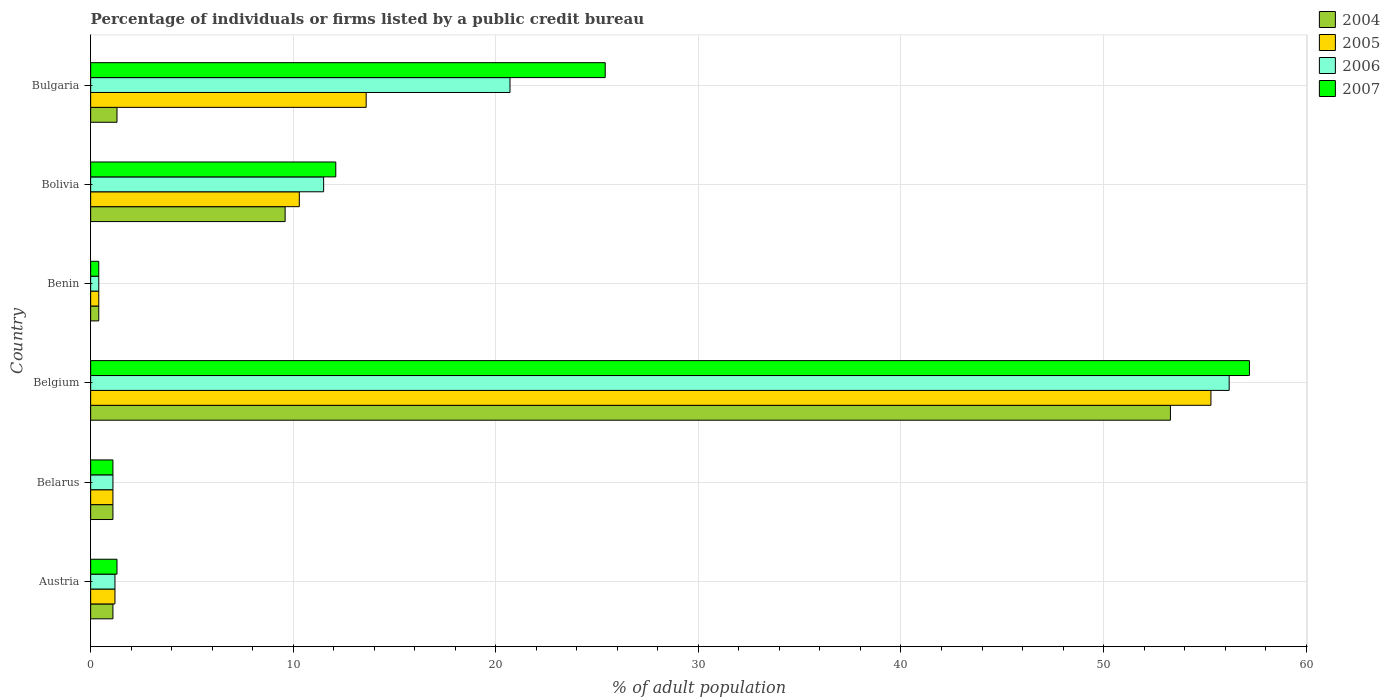How many different coloured bars are there?
Provide a succinct answer. 4. How many groups of bars are there?
Ensure brevity in your answer.  6. Are the number of bars per tick equal to the number of legend labels?
Keep it short and to the point. Yes. How many bars are there on the 1st tick from the top?
Your response must be concise. 4. How many bars are there on the 6th tick from the bottom?
Make the answer very short. 4. What is the label of the 5th group of bars from the top?
Keep it short and to the point. Belarus. Across all countries, what is the maximum percentage of population listed by a public credit bureau in 2005?
Your answer should be very brief. 55.3. Across all countries, what is the minimum percentage of population listed by a public credit bureau in 2007?
Your answer should be very brief. 0.4. In which country was the percentage of population listed by a public credit bureau in 2004 maximum?
Give a very brief answer. Belgium. In which country was the percentage of population listed by a public credit bureau in 2006 minimum?
Make the answer very short. Benin. What is the total percentage of population listed by a public credit bureau in 2005 in the graph?
Keep it short and to the point. 81.9. What is the difference between the percentage of population listed by a public credit bureau in 2007 in Belarus and that in Bulgaria?
Give a very brief answer. -24.3. What is the difference between the percentage of population listed by a public credit bureau in 2005 in Austria and the percentage of population listed by a public credit bureau in 2004 in Bulgaria?
Offer a very short reply. -0.1. What is the average percentage of population listed by a public credit bureau in 2006 per country?
Offer a very short reply. 15.18. What is the difference between the percentage of population listed by a public credit bureau in 2006 and percentage of population listed by a public credit bureau in 2007 in Bulgaria?
Make the answer very short. -4.7. In how many countries, is the percentage of population listed by a public credit bureau in 2005 greater than 38 %?
Give a very brief answer. 1. What is the ratio of the percentage of population listed by a public credit bureau in 2007 in Benin to that in Bulgaria?
Provide a succinct answer. 0.02. What is the difference between the highest and the second highest percentage of population listed by a public credit bureau in 2005?
Ensure brevity in your answer.  41.7. What is the difference between the highest and the lowest percentage of population listed by a public credit bureau in 2004?
Your answer should be compact. 52.9. In how many countries, is the percentage of population listed by a public credit bureau in 2007 greater than the average percentage of population listed by a public credit bureau in 2007 taken over all countries?
Your response must be concise. 2. Is the sum of the percentage of population listed by a public credit bureau in 2006 in Belarus and Belgium greater than the maximum percentage of population listed by a public credit bureau in 2005 across all countries?
Offer a very short reply. Yes. Is it the case that in every country, the sum of the percentage of population listed by a public credit bureau in 2004 and percentage of population listed by a public credit bureau in 2007 is greater than the sum of percentage of population listed by a public credit bureau in 2006 and percentage of population listed by a public credit bureau in 2005?
Give a very brief answer. No. What does the 1st bar from the bottom in Belgium represents?
Offer a terse response. 2004. Is it the case that in every country, the sum of the percentage of population listed by a public credit bureau in 2007 and percentage of population listed by a public credit bureau in 2005 is greater than the percentage of population listed by a public credit bureau in 2006?
Give a very brief answer. Yes. Are all the bars in the graph horizontal?
Your response must be concise. Yes. How many countries are there in the graph?
Offer a very short reply. 6. Does the graph contain grids?
Provide a short and direct response. Yes. Where does the legend appear in the graph?
Provide a succinct answer. Top right. How many legend labels are there?
Provide a short and direct response. 4. How are the legend labels stacked?
Offer a terse response. Vertical. What is the title of the graph?
Give a very brief answer. Percentage of individuals or firms listed by a public credit bureau. Does "1999" appear as one of the legend labels in the graph?
Make the answer very short. No. What is the label or title of the X-axis?
Give a very brief answer. % of adult population. What is the label or title of the Y-axis?
Give a very brief answer. Country. What is the % of adult population of 2004 in Austria?
Offer a terse response. 1.1. What is the % of adult population in 2006 in Austria?
Your answer should be very brief. 1.2. What is the % of adult population in 2004 in Belarus?
Your answer should be compact. 1.1. What is the % of adult population of 2005 in Belarus?
Give a very brief answer. 1.1. What is the % of adult population in 2004 in Belgium?
Give a very brief answer. 53.3. What is the % of adult population in 2005 in Belgium?
Your response must be concise. 55.3. What is the % of adult population in 2006 in Belgium?
Offer a very short reply. 56.2. What is the % of adult population in 2007 in Belgium?
Offer a very short reply. 57.2. What is the % of adult population of 2005 in Benin?
Your answer should be very brief. 0.4. What is the % of adult population of 2006 in Benin?
Your response must be concise. 0.4. What is the % of adult population of 2007 in Bolivia?
Keep it short and to the point. 12.1. What is the % of adult population of 2004 in Bulgaria?
Make the answer very short. 1.3. What is the % of adult population in 2005 in Bulgaria?
Give a very brief answer. 13.6. What is the % of adult population in 2006 in Bulgaria?
Make the answer very short. 20.7. What is the % of adult population of 2007 in Bulgaria?
Your answer should be compact. 25.4. Across all countries, what is the maximum % of adult population in 2004?
Keep it short and to the point. 53.3. Across all countries, what is the maximum % of adult population in 2005?
Make the answer very short. 55.3. Across all countries, what is the maximum % of adult population of 2006?
Your answer should be very brief. 56.2. Across all countries, what is the maximum % of adult population of 2007?
Keep it short and to the point. 57.2. Across all countries, what is the minimum % of adult population of 2006?
Your answer should be compact. 0.4. What is the total % of adult population in 2004 in the graph?
Offer a very short reply. 66.8. What is the total % of adult population in 2005 in the graph?
Your answer should be compact. 81.9. What is the total % of adult population of 2006 in the graph?
Your answer should be compact. 91.1. What is the total % of adult population in 2007 in the graph?
Give a very brief answer. 97.5. What is the difference between the % of adult population of 2004 in Austria and that in Belarus?
Your answer should be compact. 0. What is the difference between the % of adult population of 2005 in Austria and that in Belarus?
Keep it short and to the point. 0.1. What is the difference between the % of adult population of 2006 in Austria and that in Belarus?
Provide a succinct answer. 0.1. What is the difference between the % of adult population of 2007 in Austria and that in Belarus?
Offer a terse response. 0.2. What is the difference between the % of adult population in 2004 in Austria and that in Belgium?
Offer a very short reply. -52.2. What is the difference between the % of adult population in 2005 in Austria and that in Belgium?
Keep it short and to the point. -54.1. What is the difference between the % of adult population of 2006 in Austria and that in Belgium?
Your answer should be very brief. -55. What is the difference between the % of adult population of 2007 in Austria and that in Belgium?
Your answer should be very brief. -55.9. What is the difference between the % of adult population of 2005 in Austria and that in Benin?
Your answer should be compact. 0.8. What is the difference between the % of adult population in 2006 in Austria and that in Benin?
Offer a very short reply. 0.8. What is the difference between the % of adult population of 2007 in Austria and that in Benin?
Give a very brief answer. 0.9. What is the difference between the % of adult population of 2005 in Austria and that in Bolivia?
Offer a terse response. -9.1. What is the difference between the % of adult population of 2006 in Austria and that in Bolivia?
Your answer should be very brief. -10.3. What is the difference between the % of adult population in 2005 in Austria and that in Bulgaria?
Offer a terse response. -12.4. What is the difference between the % of adult population in 2006 in Austria and that in Bulgaria?
Your answer should be compact. -19.5. What is the difference between the % of adult population of 2007 in Austria and that in Bulgaria?
Give a very brief answer. -24.1. What is the difference between the % of adult population in 2004 in Belarus and that in Belgium?
Provide a short and direct response. -52.2. What is the difference between the % of adult population of 2005 in Belarus and that in Belgium?
Your answer should be very brief. -54.2. What is the difference between the % of adult population of 2006 in Belarus and that in Belgium?
Your answer should be very brief. -55.1. What is the difference between the % of adult population of 2007 in Belarus and that in Belgium?
Give a very brief answer. -56.1. What is the difference between the % of adult population in 2004 in Belarus and that in Benin?
Give a very brief answer. 0.7. What is the difference between the % of adult population in 2006 in Belarus and that in Benin?
Make the answer very short. 0.7. What is the difference between the % of adult population of 2007 in Belarus and that in Benin?
Make the answer very short. 0.7. What is the difference between the % of adult population of 2004 in Belarus and that in Bolivia?
Your response must be concise. -8.5. What is the difference between the % of adult population in 2006 in Belarus and that in Bolivia?
Ensure brevity in your answer.  -10.4. What is the difference between the % of adult population of 2004 in Belarus and that in Bulgaria?
Your answer should be compact. -0.2. What is the difference between the % of adult population of 2005 in Belarus and that in Bulgaria?
Your answer should be very brief. -12.5. What is the difference between the % of adult population in 2006 in Belarus and that in Bulgaria?
Offer a very short reply. -19.6. What is the difference between the % of adult population of 2007 in Belarus and that in Bulgaria?
Ensure brevity in your answer.  -24.3. What is the difference between the % of adult population of 2004 in Belgium and that in Benin?
Give a very brief answer. 52.9. What is the difference between the % of adult population in 2005 in Belgium and that in Benin?
Ensure brevity in your answer.  54.9. What is the difference between the % of adult population in 2006 in Belgium and that in Benin?
Provide a succinct answer. 55.8. What is the difference between the % of adult population in 2007 in Belgium and that in Benin?
Provide a short and direct response. 56.8. What is the difference between the % of adult population of 2004 in Belgium and that in Bolivia?
Keep it short and to the point. 43.7. What is the difference between the % of adult population in 2005 in Belgium and that in Bolivia?
Offer a terse response. 45. What is the difference between the % of adult population in 2006 in Belgium and that in Bolivia?
Your answer should be very brief. 44.7. What is the difference between the % of adult population of 2007 in Belgium and that in Bolivia?
Your response must be concise. 45.1. What is the difference between the % of adult population in 2005 in Belgium and that in Bulgaria?
Keep it short and to the point. 41.7. What is the difference between the % of adult population in 2006 in Belgium and that in Bulgaria?
Offer a very short reply. 35.5. What is the difference between the % of adult population of 2007 in Belgium and that in Bulgaria?
Ensure brevity in your answer.  31.8. What is the difference between the % of adult population of 2004 in Benin and that in Bolivia?
Provide a short and direct response. -9.2. What is the difference between the % of adult population of 2006 in Benin and that in Bolivia?
Keep it short and to the point. -11.1. What is the difference between the % of adult population in 2007 in Benin and that in Bolivia?
Your answer should be very brief. -11.7. What is the difference between the % of adult population of 2006 in Benin and that in Bulgaria?
Provide a succinct answer. -20.3. What is the difference between the % of adult population in 2007 in Benin and that in Bulgaria?
Give a very brief answer. -25. What is the difference between the % of adult population in 2004 in Bolivia and that in Bulgaria?
Keep it short and to the point. 8.3. What is the difference between the % of adult population of 2005 in Bolivia and that in Bulgaria?
Make the answer very short. -3.3. What is the difference between the % of adult population in 2006 in Bolivia and that in Bulgaria?
Offer a very short reply. -9.2. What is the difference between the % of adult population in 2007 in Bolivia and that in Bulgaria?
Provide a succinct answer. -13.3. What is the difference between the % of adult population in 2004 in Austria and the % of adult population in 2005 in Belarus?
Your answer should be very brief. 0. What is the difference between the % of adult population in 2004 in Austria and the % of adult population in 2007 in Belarus?
Provide a succinct answer. 0. What is the difference between the % of adult population of 2004 in Austria and the % of adult population of 2005 in Belgium?
Ensure brevity in your answer.  -54.2. What is the difference between the % of adult population in 2004 in Austria and the % of adult population in 2006 in Belgium?
Provide a short and direct response. -55.1. What is the difference between the % of adult population in 2004 in Austria and the % of adult population in 2007 in Belgium?
Your answer should be very brief. -56.1. What is the difference between the % of adult population of 2005 in Austria and the % of adult population of 2006 in Belgium?
Your response must be concise. -55. What is the difference between the % of adult population of 2005 in Austria and the % of adult population of 2007 in Belgium?
Offer a terse response. -56. What is the difference between the % of adult population of 2006 in Austria and the % of adult population of 2007 in Belgium?
Offer a very short reply. -56. What is the difference between the % of adult population of 2004 in Austria and the % of adult population of 2005 in Benin?
Make the answer very short. 0.7. What is the difference between the % of adult population of 2004 in Austria and the % of adult population of 2007 in Benin?
Give a very brief answer. 0.7. What is the difference between the % of adult population in 2005 in Austria and the % of adult population in 2006 in Benin?
Provide a succinct answer. 0.8. What is the difference between the % of adult population of 2004 in Austria and the % of adult population of 2005 in Bolivia?
Offer a terse response. -9.2. What is the difference between the % of adult population in 2004 in Austria and the % of adult population in 2007 in Bolivia?
Provide a short and direct response. -11. What is the difference between the % of adult population in 2005 in Austria and the % of adult population in 2006 in Bolivia?
Your answer should be very brief. -10.3. What is the difference between the % of adult population of 2005 in Austria and the % of adult population of 2007 in Bolivia?
Your response must be concise. -10.9. What is the difference between the % of adult population in 2006 in Austria and the % of adult population in 2007 in Bolivia?
Keep it short and to the point. -10.9. What is the difference between the % of adult population in 2004 in Austria and the % of adult population in 2006 in Bulgaria?
Provide a short and direct response. -19.6. What is the difference between the % of adult population in 2004 in Austria and the % of adult population in 2007 in Bulgaria?
Offer a very short reply. -24.3. What is the difference between the % of adult population in 2005 in Austria and the % of adult population in 2006 in Bulgaria?
Your answer should be compact. -19.5. What is the difference between the % of adult population in 2005 in Austria and the % of adult population in 2007 in Bulgaria?
Offer a terse response. -24.2. What is the difference between the % of adult population of 2006 in Austria and the % of adult population of 2007 in Bulgaria?
Provide a short and direct response. -24.2. What is the difference between the % of adult population in 2004 in Belarus and the % of adult population in 2005 in Belgium?
Provide a short and direct response. -54.2. What is the difference between the % of adult population in 2004 in Belarus and the % of adult population in 2006 in Belgium?
Give a very brief answer. -55.1. What is the difference between the % of adult population in 2004 in Belarus and the % of adult population in 2007 in Belgium?
Give a very brief answer. -56.1. What is the difference between the % of adult population in 2005 in Belarus and the % of adult population in 2006 in Belgium?
Offer a terse response. -55.1. What is the difference between the % of adult population of 2005 in Belarus and the % of adult population of 2007 in Belgium?
Your answer should be compact. -56.1. What is the difference between the % of adult population in 2006 in Belarus and the % of adult population in 2007 in Belgium?
Offer a very short reply. -56.1. What is the difference between the % of adult population of 2004 in Belarus and the % of adult population of 2006 in Benin?
Keep it short and to the point. 0.7. What is the difference between the % of adult population of 2004 in Belarus and the % of adult population of 2007 in Benin?
Your answer should be compact. 0.7. What is the difference between the % of adult population in 2005 in Belarus and the % of adult population in 2006 in Benin?
Keep it short and to the point. 0.7. What is the difference between the % of adult population in 2006 in Belarus and the % of adult population in 2007 in Benin?
Your answer should be compact. 0.7. What is the difference between the % of adult population of 2004 in Belarus and the % of adult population of 2006 in Bolivia?
Provide a succinct answer. -10.4. What is the difference between the % of adult population in 2005 in Belarus and the % of adult population in 2006 in Bolivia?
Offer a very short reply. -10.4. What is the difference between the % of adult population in 2005 in Belarus and the % of adult population in 2007 in Bolivia?
Keep it short and to the point. -11. What is the difference between the % of adult population of 2004 in Belarus and the % of adult population of 2006 in Bulgaria?
Offer a terse response. -19.6. What is the difference between the % of adult population in 2004 in Belarus and the % of adult population in 2007 in Bulgaria?
Keep it short and to the point. -24.3. What is the difference between the % of adult population in 2005 in Belarus and the % of adult population in 2006 in Bulgaria?
Your response must be concise. -19.6. What is the difference between the % of adult population of 2005 in Belarus and the % of adult population of 2007 in Bulgaria?
Your answer should be very brief. -24.3. What is the difference between the % of adult population of 2006 in Belarus and the % of adult population of 2007 in Bulgaria?
Ensure brevity in your answer.  -24.3. What is the difference between the % of adult population of 2004 in Belgium and the % of adult population of 2005 in Benin?
Provide a short and direct response. 52.9. What is the difference between the % of adult population in 2004 in Belgium and the % of adult population in 2006 in Benin?
Offer a very short reply. 52.9. What is the difference between the % of adult population of 2004 in Belgium and the % of adult population of 2007 in Benin?
Give a very brief answer. 52.9. What is the difference between the % of adult population in 2005 in Belgium and the % of adult population in 2006 in Benin?
Ensure brevity in your answer.  54.9. What is the difference between the % of adult population in 2005 in Belgium and the % of adult population in 2007 in Benin?
Ensure brevity in your answer.  54.9. What is the difference between the % of adult population in 2006 in Belgium and the % of adult population in 2007 in Benin?
Make the answer very short. 55.8. What is the difference between the % of adult population of 2004 in Belgium and the % of adult population of 2005 in Bolivia?
Your answer should be very brief. 43. What is the difference between the % of adult population in 2004 in Belgium and the % of adult population in 2006 in Bolivia?
Offer a very short reply. 41.8. What is the difference between the % of adult population in 2004 in Belgium and the % of adult population in 2007 in Bolivia?
Your answer should be compact. 41.2. What is the difference between the % of adult population in 2005 in Belgium and the % of adult population in 2006 in Bolivia?
Ensure brevity in your answer.  43.8. What is the difference between the % of adult population in 2005 in Belgium and the % of adult population in 2007 in Bolivia?
Your answer should be compact. 43.2. What is the difference between the % of adult population of 2006 in Belgium and the % of adult population of 2007 in Bolivia?
Keep it short and to the point. 44.1. What is the difference between the % of adult population of 2004 in Belgium and the % of adult population of 2005 in Bulgaria?
Your answer should be very brief. 39.7. What is the difference between the % of adult population of 2004 in Belgium and the % of adult population of 2006 in Bulgaria?
Your answer should be very brief. 32.6. What is the difference between the % of adult population in 2004 in Belgium and the % of adult population in 2007 in Bulgaria?
Provide a short and direct response. 27.9. What is the difference between the % of adult population of 2005 in Belgium and the % of adult population of 2006 in Bulgaria?
Provide a short and direct response. 34.6. What is the difference between the % of adult population of 2005 in Belgium and the % of adult population of 2007 in Bulgaria?
Offer a very short reply. 29.9. What is the difference between the % of adult population in 2006 in Belgium and the % of adult population in 2007 in Bulgaria?
Make the answer very short. 30.8. What is the difference between the % of adult population of 2004 in Benin and the % of adult population of 2006 in Bolivia?
Provide a succinct answer. -11.1. What is the difference between the % of adult population of 2005 in Benin and the % of adult population of 2006 in Bolivia?
Offer a very short reply. -11.1. What is the difference between the % of adult population of 2005 in Benin and the % of adult population of 2007 in Bolivia?
Give a very brief answer. -11.7. What is the difference between the % of adult population of 2004 in Benin and the % of adult population of 2005 in Bulgaria?
Provide a short and direct response. -13.2. What is the difference between the % of adult population of 2004 in Benin and the % of adult population of 2006 in Bulgaria?
Provide a succinct answer. -20.3. What is the difference between the % of adult population of 2004 in Benin and the % of adult population of 2007 in Bulgaria?
Your response must be concise. -25. What is the difference between the % of adult population of 2005 in Benin and the % of adult population of 2006 in Bulgaria?
Your answer should be very brief. -20.3. What is the difference between the % of adult population in 2005 in Benin and the % of adult population in 2007 in Bulgaria?
Offer a terse response. -25. What is the difference between the % of adult population in 2004 in Bolivia and the % of adult population in 2006 in Bulgaria?
Your response must be concise. -11.1. What is the difference between the % of adult population in 2004 in Bolivia and the % of adult population in 2007 in Bulgaria?
Keep it short and to the point. -15.8. What is the difference between the % of adult population of 2005 in Bolivia and the % of adult population of 2007 in Bulgaria?
Your answer should be very brief. -15.1. What is the difference between the % of adult population in 2006 in Bolivia and the % of adult population in 2007 in Bulgaria?
Give a very brief answer. -13.9. What is the average % of adult population in 2004 per country?
Provide a short and direct response. 11.13. What is the average % of adult population of 2005 per country?
Give a very brief answer. 13.65. What is the average % of adult population of 2006 per country?
Make the answer very short. 15.18. What is the average % of adult population of 2007 per country?
Offer a terse response. 16.25. What is the difference between the % of adult population in 2004 and % of adult population in 2005 in Austria?
Ensure brevity in your answer.  -0.1. What is the difference between the % of adult population of 2004 and % of adult population of 2007 in Austria?
Your response must be concise. -0.2. What is the difference between the % of adult population in 2005 and % of adult population in 2006 in Austria?
Offer a terse response. 0. What is the difference between the % of adult population in 2006 and % of adult population in 2007 in Austria?
Ensure brevity in your answer.  -0.1. What is the difference between the % of adult population in 2004 and % of adult population in 2005 in Belarus?
Your answer should be very brief. 0. What is the difference between the % of adult population of 2006 and % of adult population of 2007 in Belarus?
Offer a very short reply. 0. What is the difference between the % of adult population of 2004 and % of adult population of 2005 in Belgium?
Your answer should be very brief. -2. What is the difference between the % of adult population of 2005 and % of adult population of 2007 in Belgium?
Your answer should be very brief. -1.9. What is the difference between the % of adult population in 2006 and % of adult population in 2007 in Belgium?
Keep it short and to the point. -1. What is the difference between the % of adult population of 2004 and % of adult population of 2006 in Benin?
Provide a short and direct response. 0. What is the difference between the % of adult population in 2004 and % of adult population in 2007 in Benin?
Give a very brief answer. 0. What is the difference between the % of adult population of 2006 and % of adult population of 2007 in Benin?
Your response must be concise. 0. What is the difference between the % of adult population of 2004 and % of adult population of 2005 in Bolivia?
Give a very brief answer. -0.7. What is the difference between the % of adult population in 2004 and % of adult population in 2006 in Bolivia?
Offer a very short reply. -1.9. What is the difference between the % of adult population of 2004 and % of adult population of 2007 in Bolivia?
Offer a very short reply. -2.5. What is the difference between the % of adult population of 2006 and % of adult population of 2007 in Bolivia?
Provide a succinct answer. -0.6. What is the difference between the % of adult population of 2004 and % of adult population of 2006 in Bulgaria?
Your answer should be compact. -19.4. What is the difference between the % of adult population in 2004 and % of adult population in 2007 in Bulgaria?
Your answer should be compact. -24.1. What is the difference between the % of adult population of 2005 and % of adult population of 2006 in Bulgaria?
Provide a succinct answer. -7.1. What is the difference between the % of adult population in 2006 and % of adult population in 2007 in Bulgaria?
Your answer should be compact. -4.7. What is the ratio of the % of adult population of 2005 in Austria to that in Belarus?
Give a very brief answer. 1.09. What is the ratio of the % of adult population of 2006 in Austria to that in Belarus?
Your response must be concise. 1.09. What is the ratio of the % of adult population in 2007 in Austria to that in Belarus?
Offer a very short reply. 1.18. What is the ratio of the % of adult population of 2004 in Austria to that in Belgium?
Keep it short and to the point. 0.02. What is the ratio of the % of adult population in 2005 in Austria to that in Belgium?
Your answer should be very brief. 0.02. What is the ratio of the % of adult population of 2006 in Austria to that in Belgium?
Make the answer very short. 0.02. What is the ratio of the % of adult population of 2007 in Austria to that in Belgium?
Your response must be concise. 0.02. What is the ratio of the % of adult population in 2004 in Austria to that in Benin?
Your response must be concise. 2.75. What is the ratio of the % of adult population in 2007 in Austria to that in Benin?
Your answer should be very brief. 3.25. What is the ratio of the % of adult population of 2004 in Austria to that in Bolivia?
Your answer should be very brief. 0.11. What is the ratio of the % of adult population of 2005 in Austria to that in Bolivia?
Provide a short and direct response. 0.12. What is the ratio of the % of adult population of 2006 in Austria to that in Bolivia?
Keep it short and to the point. 0.1. What is the ratio of the % of adult population in 2007 in Austria to that in Bolivia?
Ensure brevity in your answer.  0.11. What is the ratio of the % of adult population of 2004 in Austria to that in Bulgaria?
Provide a short and direct response. 0.85. What is the ratio of the % of adult population of 2005 in Austria to that in Bulgaria?
Provide a succinct answer. 0.09. What is the ratio of the % of adult population of 2006 in Austria to that in Bulgaria?
Offer a very short reply. 0.06. What is the ratio of the % of adult population of 2007 in Austria to that in Bulgaria?
Keep it short and to the point. 0.05. What is the ratio of the % of adult population of 2004 in Belarus to that in Belgium?
Offer a terse response. 0.02. What is the ratio of the % of adult population of 2005 in Belarus to that in Belgium?
Your response must be concise. 0.02. What is the ratio of the % of adult population of 2006 in Belarus to that in Belgium?
Provide a succinct answer. 0.02. What is the ratio of the % of adult population in 2007 in Belarus to that in Belgium?
Provide a short and direct response. 0.02. What is the ratio of the % of adult population in 2004 in Belarus to that in Benin?
Your response must be concise. 2.75. What is the ratio of the % of adult population of 2005 in Belarus to that in Benin?
Your answer should be compact. 2.75. What is the ratio of the % of adult population in 2006 in Belarus to that in Benin?
Your answer should be compact. 2.75. What is the ratio of the % of adult population of 2007 in Belarus to that in Benin?
Provide a short and direct response. 2.75. What is the ratio of the % of adult population in 2004 in Belarus to that in Bolivia?
Provide a short and direct response. 0.11. What is the ratio of the % of adult population in 2005 in Belarus to that in Bolivia?
Keep it short and to the point. 0.11. What is the ratio of the % of adult population of 2006 in Belarus to that in Bolivia?
Your answer should be very brief. 0.1. What is the ratio of the % of adult population in 2007 in Belarus to that in Bolivia?
Provide a short and direct response. 0.09. What is the ratio of the % of adult population in 2004 in Belarus to that in Bulgaria?
Offer a very short reply. 0.85. What is the ratio of the % of adult population in 2005 in Belarus to that in Bulgaria?
Ensure brevity in your answer.  0.08. What is the ratio of the % of adult population of 2006 in Belarus to that in Bulgaria?
Your response must be concise. 0.05. What is the ratio of the % of adult population in 2007 in Belarus to that in Bulgaria?
Give a very brief answer. 0.04. What is the ratio of the % of adult population of 2004 in Belgium to that in Benin?
Offer a very short reply. 133.25. What is the ratio of the % of adult population in 2005 in Belgium to that in Benin?
Your answer should be very brief. 138.25. What is the ratio of the % of adult population in 2006 in Belgium to that in Benin?
Provide a short and direct response. 140.5. What is the ratio of the % of adult population of 2007 in Belgium to that in Benin?
Provide a short and direct response. 143. What is the ratio of the % of adult population in 2004 in Belgium to that in Bolivia?
Make the answer very short. 5.55. What is the ratio of the % of adult population of 2005 in Belgium to that in Bolivia?
Your answer should be compact. 5.37. What is the ratio of the % of adult population in 2006 in Belgium to that in Bolivia?
Your response must be concise. 4.89. What is the ratio of the % of adult population in 2007 in Belgium to that in Bolivia?
Ensure brevity in your answer.  4.73. What is the ratio of the % of adult population in 2004 in Belgium to that in Bulgaria?
Provide a short and direct response. 41. What is the ratio of the % of adult population of 2005 in Belgium to that in Bulgaria?
Offer a terse response. 4.07. What is the ratio of the % of adult population in 2006 in Belgium to that in Bulgaria?
Make the answer very short. 2.71. What is the ratio of the % of adult population in 2007 in Belgium to that in Bulgaria?
Your response must be concise. 2.25. What is the ratio of the % of adult population in 2004 in Benin to that in Bolivia?
Provide a short and direct response. 0.04. What is the ratio of the % of adult population in 2005 in Benin to that in Bolivia?
Your answer should be very brief. 0.04. What is the ratio of the % of adult population in 2006 in Benin to that in Bolivia?
Give a very brief answer. 0.03. What is the ratio of the % of adult population in 2007 in Benin to that in Bolivia?
Give a very brief answer. 0.03. What is the ratio of the % of adult population of 2004 in Benin to that in Bulgaria?
Give a very brief answer. 0.31. What is the ratio of the % of adult population of 2005 in Benin to that in Bulgaria?
Keep it short and to the point. 0.03. What is the ratio of the % of adult population of 2006 in Benin to that in Bulgaria?
Provide a succinct answer. 0.02. What is the ratio of the % of adult population in 2007 in Benin to that in Bulgaria?
Your answer should be compact. 0.02. What is the ratio of the % of adult population of 2004 in Bolivia to that in Bulgaria?
Provide a short and direct response. 7.38. What is the ratio of the % of adult population of 2005 in Bolivia to that in Bulgaria?
Your answer should be very brief. 0.76. What is the ratio of the % of adult population in 2006 in Bolivia to that in Bulgaria?
Offer a terse response. 0.56. What is the ratio of the % of adult population of 2007 in Bolivia to that in Bulgaria?
Offer a terse response. 0.48. What is the difference between the highest and the second highest % of adult population of 2004?
Provide a succinct answer. 43.7. What is the difference between the highest and the second highest % of adult population in 2005?
Your answer should be very brief. 41.7. What is the difference between the highest and the second highest % of adult population of 2006?
Your answer should be very brief. 35.5. What is the difference between the highest and the second highest % of adult population in 2007?
Provide a short and direct response. 31.8. What is the difference between the highest and the lowest % of adult population of 2004?
Provide a succinct answer. 52.9. What is the difference between the highest and the lowest % of adult population of 2005?
Offer a very short reply. 54.9. What is the difference between the highest and the lowest % of adult population of 2006?
Keep it short and to the point. 55.8. What is the difference between the highest and the lowest % of adult population in 2007?
Give a very brief answer. 56.8. 